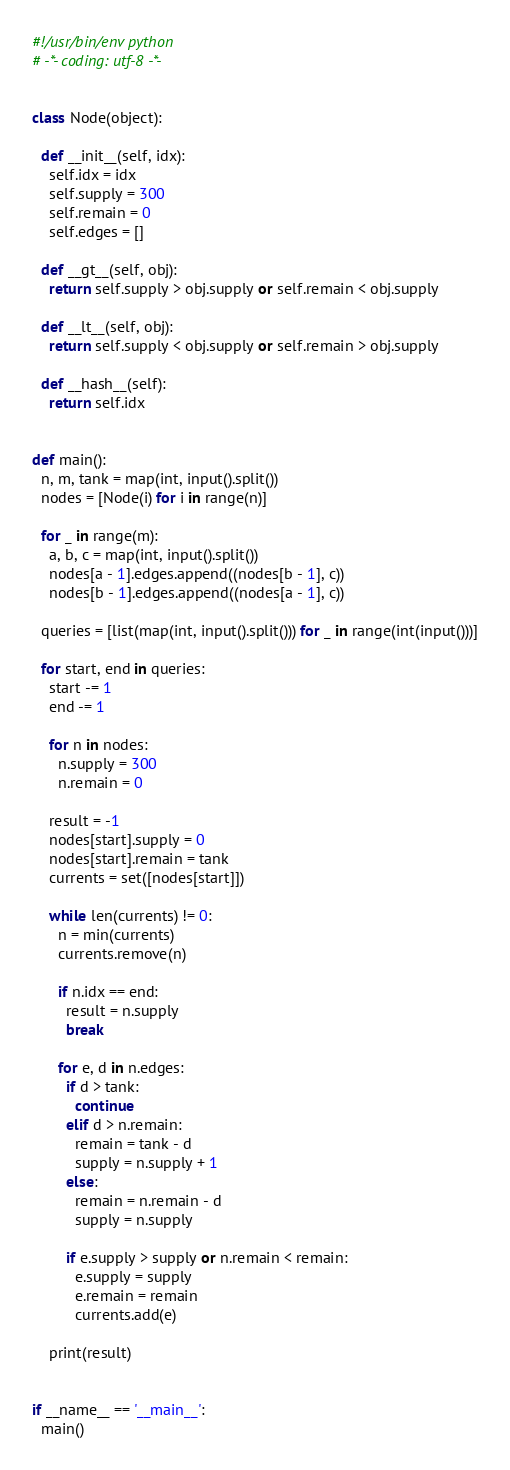Convert code to text. <code><loc_0><loc_0><loc_500><loc_500><_Python_>#!/usr/bin/env python
# -*- coding: utf-8 -*-


class Node(object):

  def __init__(self, idx):
    self.idx = idx
    self.supply = 300
    self.remain = 0
    self.edges = []

  def __gt__(self, obj):
    return self.supply > obj.supply or self.remain < obj.supply

  def __lt__(self, obj):
    return self.supply < obj.supply or self.remain > obj.supply

  def __hash__(self):
    return self.idx


def main():
  n, m, tank = map(int, input().split())
  nodes = [Node(i) for i in range(n)]

  for _ in range(m):
    a, b, c = map(int, input().split())
    nodes[a - 1].edges.append((nodes[b - 1], c))
    nodes[b - 1].edges.append((nodes[a - 1], c))

  queries = [list(map(int, input().split())) for _ in range(int(input()))]

  for start, end in queries:
    start -= 1
    end -= 1

    for n in nodes:
      n.supply = 300
      n.remain = 0

    result = -1
    nodes[start].supply = 0
    nodes[start].remain = tank
    currents = set([nodes[start]])

    while len(currents) != 0:
      n = min(currents)
      currents.remove(n)

      if n.idx == end:
        result = n.supply
        break

      for e, d in n.edges:
        if d > tank:
          continue
        elif d > n.remain:
          remain = tank - d
          supply = n.supply + 1
        else:
          remain = n.remain - d
          supply = n.supply

        if e.supply > supply or n.remain < remain:
          e.supply = supply
          e.remain = remain
          currents.add(e)

    print(result)


if __name__ == '__main__':
  main()

</code> 